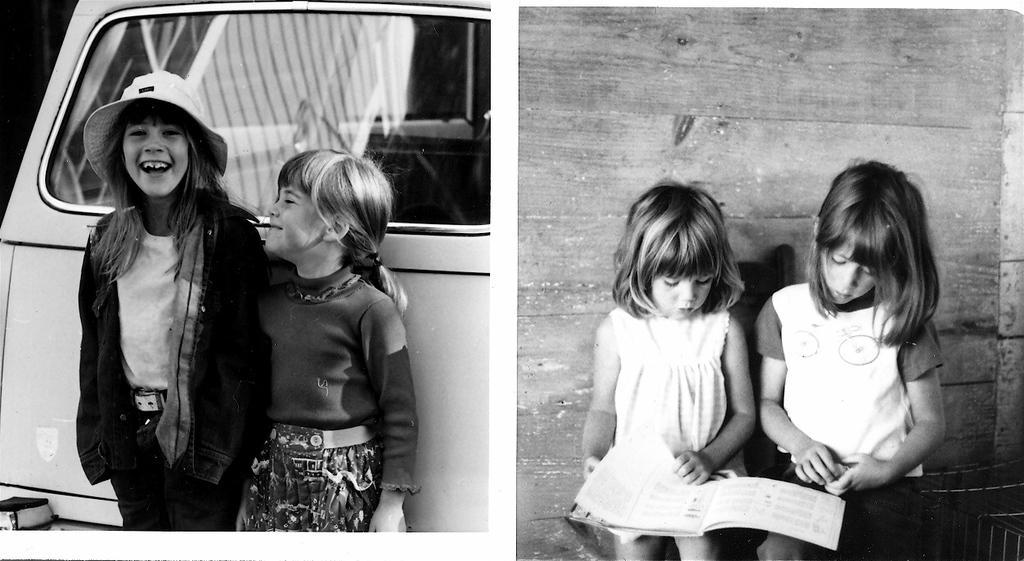Can you describe this image briefly? In this image on the right side there are two girls looking into a book. On the left side there are other two girls who are smiling. 